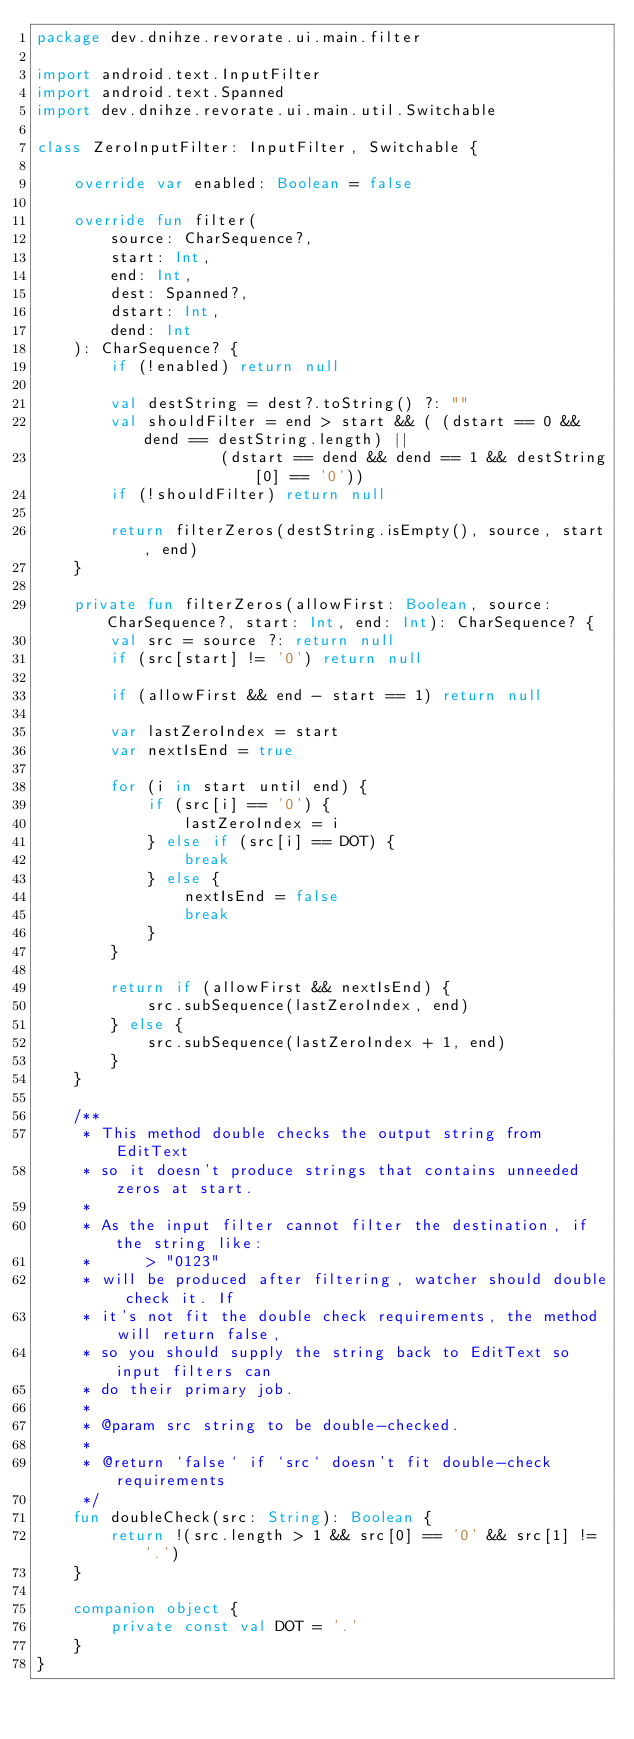Convert code to text. <code><loc_0><loc_0><loc_500><loc_500><_Kotlin_>package dev.dnihze.revorate.ui.main.filter

import android.text.InputFilter
import android.text.Spanned
import dev.dnihze.revorate.ui.main.util.Switchable

class ZeroInputFilter: InputFilter, Switchable {

    override var enabled: Boolean = false

    override fun filter(
        source: CharSequence?,
        start: Int,
        end: Int,
        dest: Spanned?,
        dstart: Int,
        dend: Int
    ): CharSequence? {
        if (!enabled) return null

        val destString = dest?.toString() ?: ""
        val shouldFilter = end > start && ( (dstart == 0 && dend == destString.length) ||
                    (dstart == dend && dend == 1 && destString[0] == '0'))
        if (!shouldFilter) return null

        return filterZeros(destString.isEmpty(), source, start, end)
    }

    private fun filterZeros(allowFirst: Boolean, source: CharSequence?, start: Int, end: Int): CharSequence? {
        val src = source ?: return null
        if (src[start] != '0') return null

        if (allowFirst && end - start == 1) return null

        var lastZeroIndex = start
        var nextIsEnd = true

        for (i in start until end) {
            if (src[i] == '0') {
                lastZeroIndex = i
            } else if (src[i] == DOT) {
                break
            } else {
                nextIsEnd = false
                break
            }
        }

        return if (allowFirst && nextIsEnd) {
            src.subSequence(lastZeroIndex, end)
        } else {
            src.subSequence(lastZeroIndex + 1, end)
        }
    }

    /**
     * This method double checks the output string from EditText
     * so it doesn't produce strings that contains unneeded zeros at start.
     *
     * As the input filter cannot filter the destination, if the string like:
     *      > "0123"
     * will be produced after filtering, watcher should double check it. If
     * it's not fit the double check requirements, the method will return false,
     * so you should supply the string back to EditText so input filters can
     * do their primary job.
     *
     * @param src string to be double-checked.
     *
     * @return `false` if `src` doesn't fit double-check requirements
     */
    fun doubleCheck(src: String): Boolean {
        return !(src.length > 1 && src[0] == '0' && src[1] != '.')
    }

    companion object {
        private const val DOT = '.'
    }
}</code> 